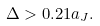Convert formula to latex. <formula><loc_0><loc_0><loc_500><loc_500>\Delta > 0 . 2 1 a _ { J } .</formula> 